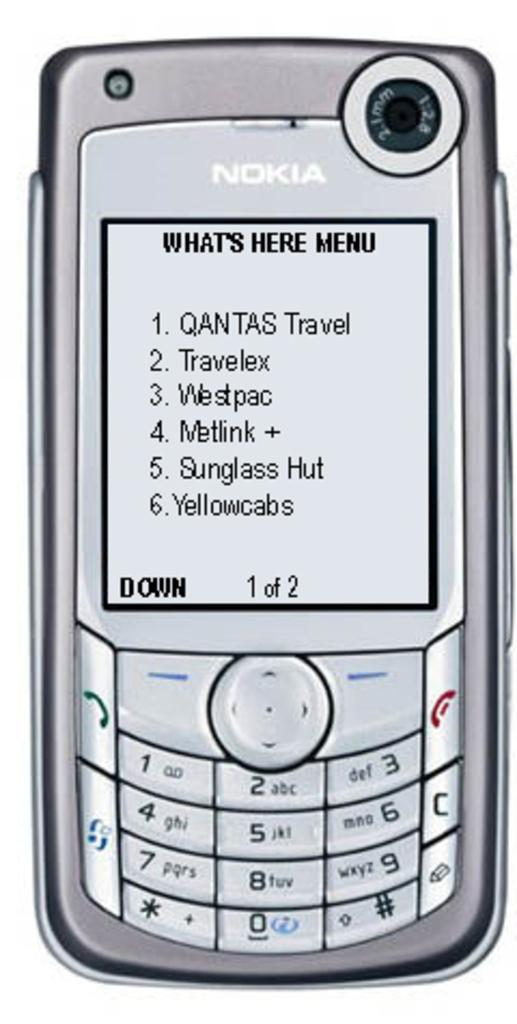Provide a one-sentence caption for the provided image. Nokia phone that says What's Here Menu and says Down 1 of 2. 